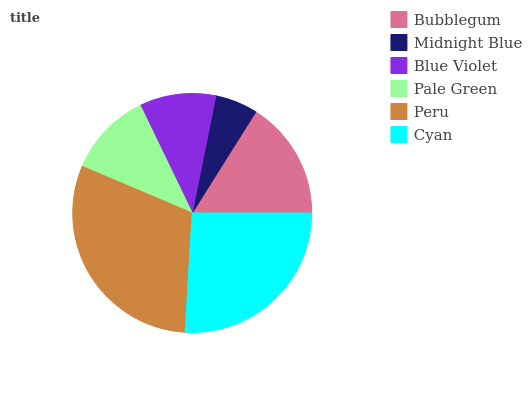Is Midnight Blue the minimum?
Answer yes or no. Yes. Is Peru the maximum?
Answer yes or no. Yes. Is Blue Violet the minimum?
Answer yes or no. No. Is Blue Violet the maximum?
Answer yes or no. No. Is Blue Violet greater than Midnight Blue?
Answer yes or no. Yes. Is Midnight Blue less than Blue Violet?
Answer yes or no. Yes. Is Midnight Blue greater than Blue Violet?
Answer yes or no. No. Is Blue Violet less than Midnight Blue?
Answer yes or no. No. Is Bubblegum the high median?
Answer yes or no. Yes. Is Pale Green the low median?
Answer yes or no. Yes. Is Peru the high median?
Answer yes or no. No. Is Cyan the low median?
Answer yes or no. No. 